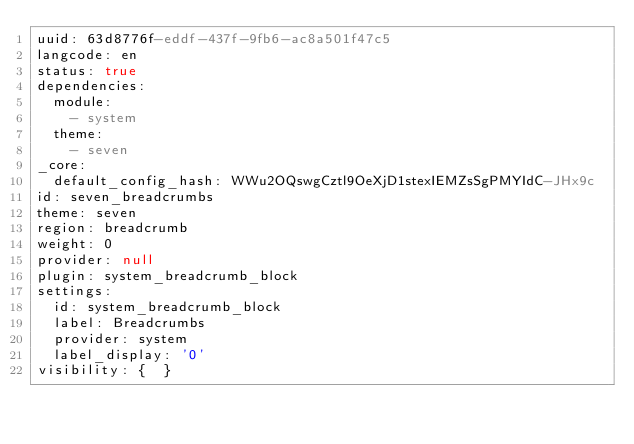Convert code to text. <code><loc_0><loc_0><loc_500><loc_500><_YAML_>uuid: 63d8776f-eddf-437f-9fb6-ac8a501f47c5
langcode: en
status: true
dependencies:
  module:
    - system
  theme:
    - seven
_core:
  default_config_hash: WWu2OQswgCztl9OeXjD1stexIEMZsSgPMYIdC-JHx9c
id: seven_breadcrumbs
theme: seven
region: breadcrumb
weight: 0
provider: null
plugin: system_breadcrumb_block
settings:
  id: system_breadcrumb_block
  label: Breadcrumbs
  provider: system
  label_display: '0'
visibility: {  }
</code> 